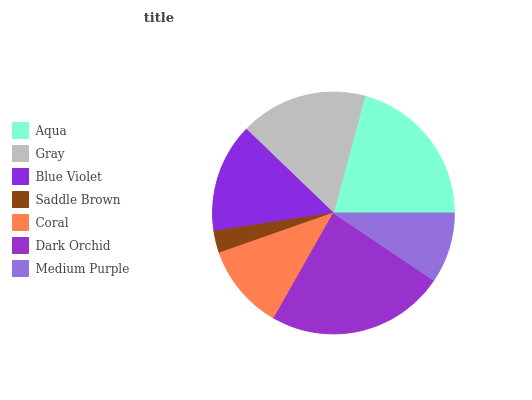Is Saddle Brown the minimum?
Answer yes or no. Yes. Is Dark Orchid the maximum?
Answer yes or no. Yes. Is Gray the minimum?
Answer yes or no. No. Is Gray the maximum?
Answer yes or no. No. Is Aqua greater than Gray?
Answer yes or no. Yes. Is Gray less than Aqua?
Answer yes or no. Yes. Is Gray greater than Aqua?
Answer yes or no. No. Is Aqua less than Gray?
Answer yes or no. No. Is Blue Violet the high median?
Answer yes or no. Yes. Is Blue Violet the low median?
Answer yes or no. Yes. Is Saddle Brown the high median?
Answer yes or no. No. Is Coral the low median?
Answer yes or no. No. 